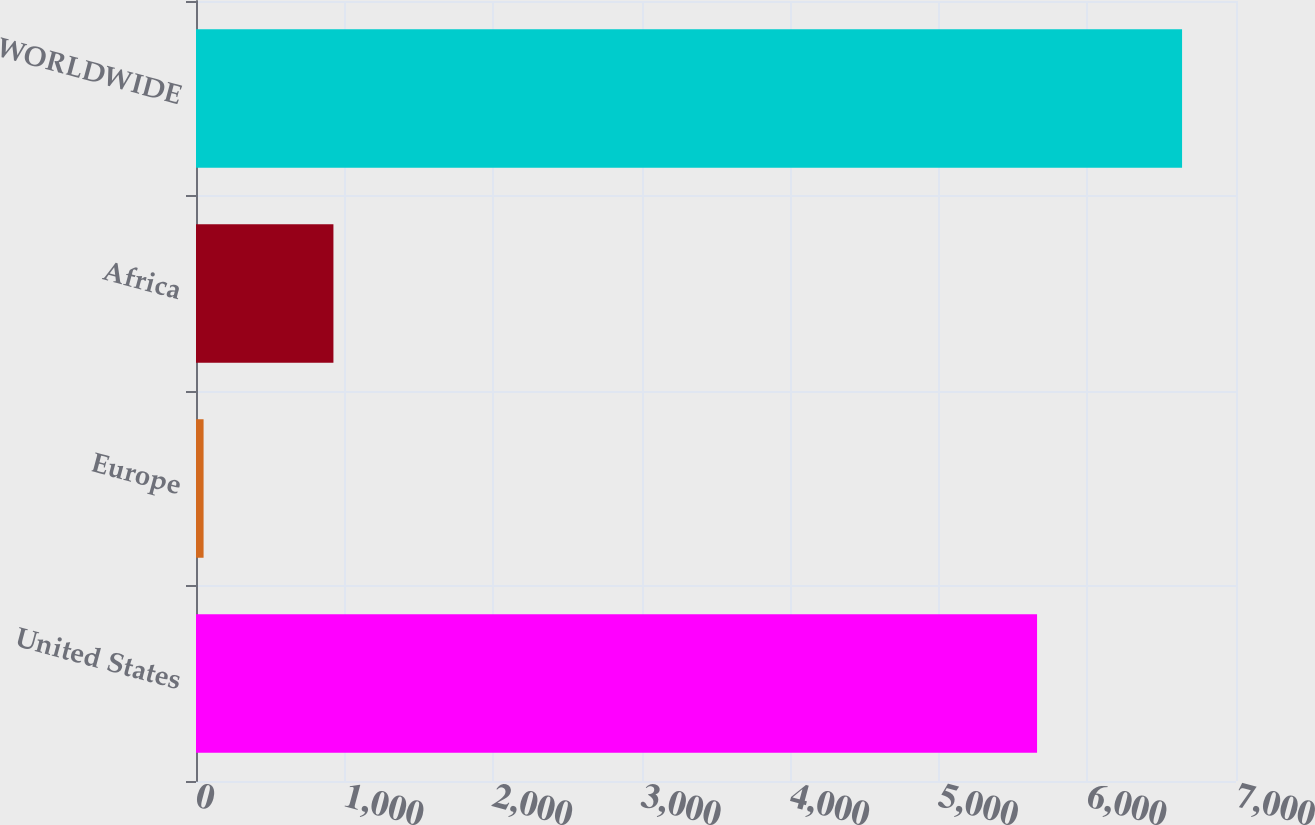Convert chart to OTSL. <chart><loc_0><loc_0><loc_500><loc_500><bar_chart><fcel>United States<fcel>Europe<fcel>Africa<fcel>WORLDWIDE<nl><fcel>5661<fcel>51<fcel>925<fcel>6637<nl></chart> 